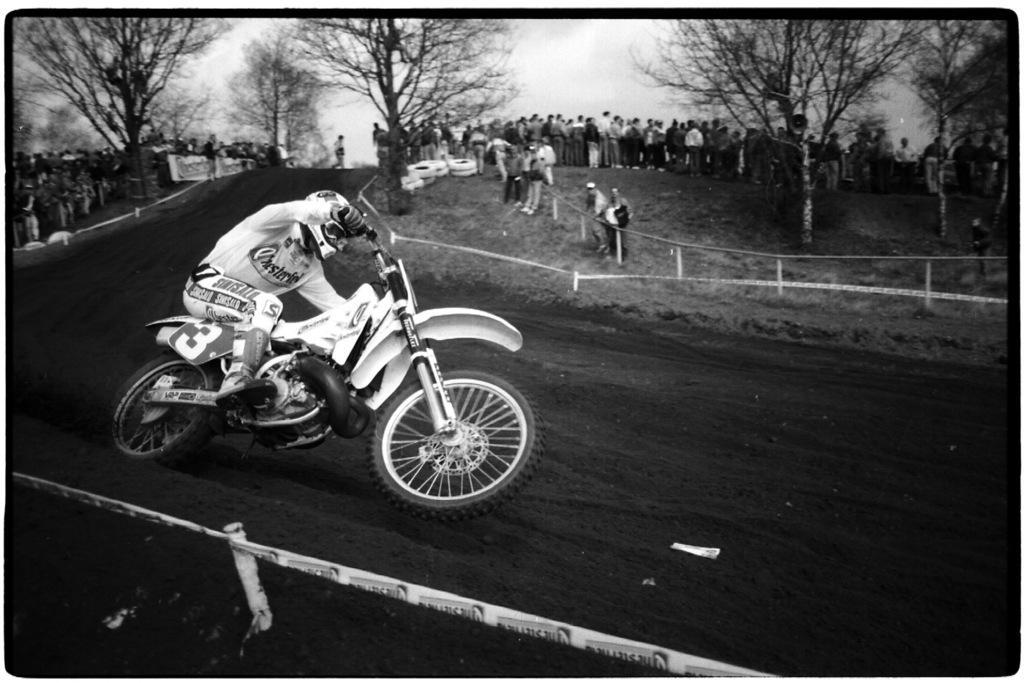Please provide a concise description of this image. Here we can see a person riding a motor bike on a race track and behind him we can see number of people standing and seeing him and there are number of trees present 